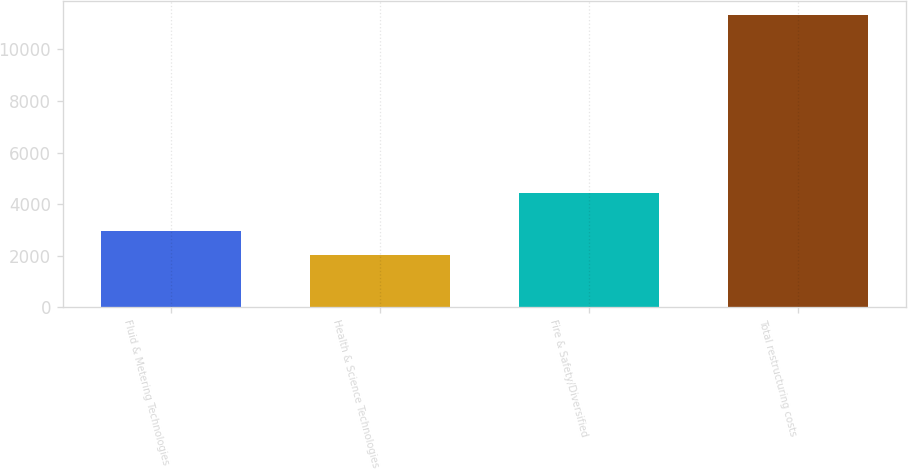Convert chart. <chart><loc_0><loc_0><loc_500><loc_500><bar_chart><fcel>Fluid & Metering Technologies<fcel>Health & Science Technologies<fcel>Fire & Safety/Diversified<fcel>Total restructuring costs<nl><fcel>2939.6<fcel>2007<fcel>4430<fcel>11333<nl></chart> 